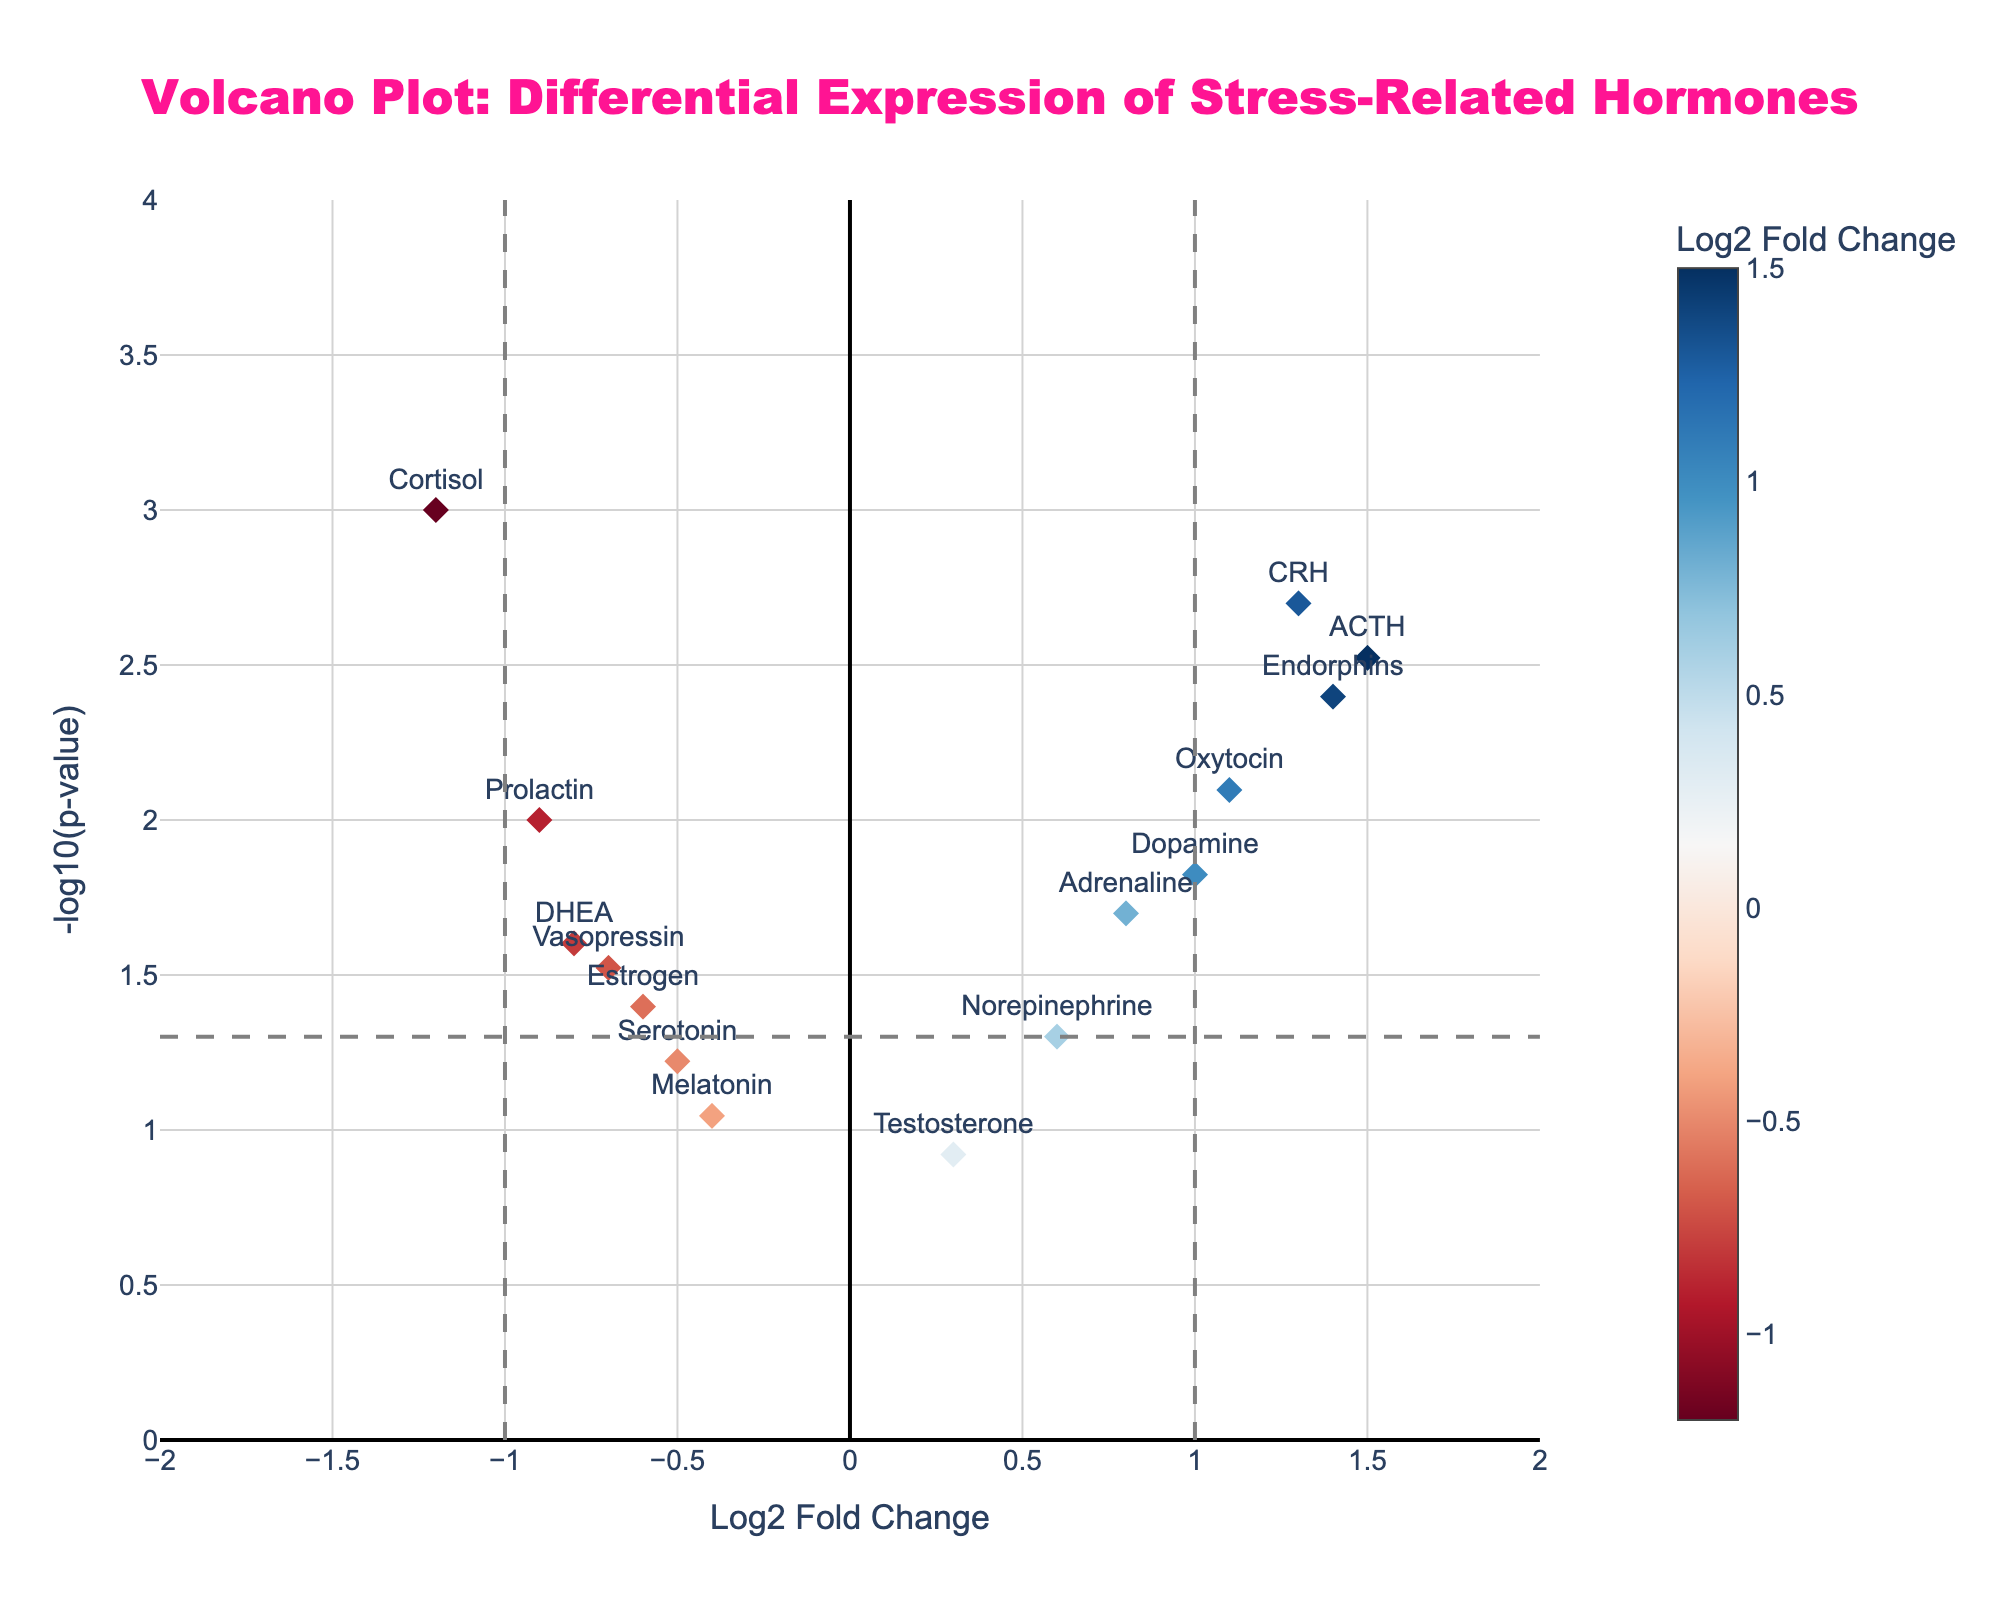What is the title of the plot? The title is displayed at the top of the plot in large, bold, and pink font. It summarizes what the plot is representing.
Answer: Volcano Plot: Differential Expression of Stress-Related Hormones How many hormones have a Log2 Fold Change greater than 1? Log2 Fold Change is displayed on the x-axis. The points to the right of the vertical line at x=1 represent hormones with a Log2 Fold Change greater than 1. Specifically, ACTH, CRH, Endorphins, and Oxytocin meet this criterion.
Answer: Four hormones Which hormone shows the lowest p-value in the plot? P-values are transformed to -log10 and shown on the y-axis. The higher the -log10(p-value), the lower the original p-value. The point at the highest y value corresponds to the lowest p-value which, in this plot, is Cortisol.
Answer: Cortisol What hormone has the most negative Log2 Fold Change and what is its approximate p-value? Cortisol has the most negative Log2 Fold Change at -1.2. Looking at its y-axis position, the approximate p-value can be inferred from -log10(p-value), which is around 3.
Answer: Cortisol with p-value around 0.001 What Log2 Fold Change threshold is marked by vertical lines in the plot? The plot has vertical dashed lines at x = -1 and x = 1, indicating these as threshold points for Log2 Fold Change.
Answer: -1 and 1 What is the significance threshold for p-values marked by horizontal lines in the plot? The plot has a horizontal dashed line that marks the significance threshold for p-values on the y-axis at -log10(p-value) ≈ 1.30, which indicates a p-value of 0.05.
Answer: 0.05 How many hormones have statistically significant changes in their expression levels? Statistically significant p-values are below 0.05, represented by points above the horizontal line at -log10(0.05). Counting these points above the line gives Cortisol, ACTH, Endorphins, CRH, Prolactin, Dopamine, Oxytocin, Vasopressin, Adrenaline, and DHEA.
Answer: Ten hormones Which hormone has a Log2 Fold Change closest to zero but statistically significant? Dopamine has a Log2 Fold Change of 1.0, which is the closest to zero amongst the statistically significant hormones (p-value below 0.05).
Answer: Dopamine Which hormones are upregulated and have very low p-values? Upregulated hormones are those with positive Log2 Fold Change values. Low p-values are indicated by high positions on the y-axis. ACTH, CRH, Endorphins, and Oxytocin are upregulated with p-values below 0.05.
Answer: ACTH, CRH, Endorphins, Oxytocin What is the Log2 Fold Change and significance of serotonin? Serotonin's Log2 Fold Change is -0.5, and its significance (p-value) is represented on the y-axis, being slightly above 1 on -log10 scale, indicating p ≈ 0.06.
Answer: Log2 Fold Change: -0.5, p-value: ≈0.06 